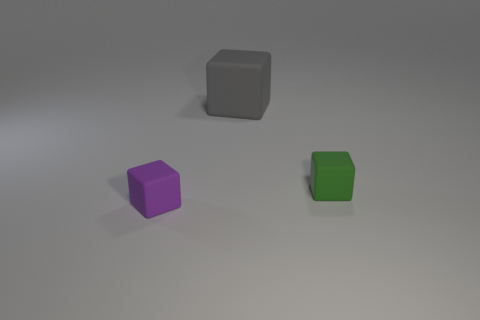Which of these blocks is the largest? Based on the perspective shown in the image, the gray block appears to be the largest among the three blocks. 